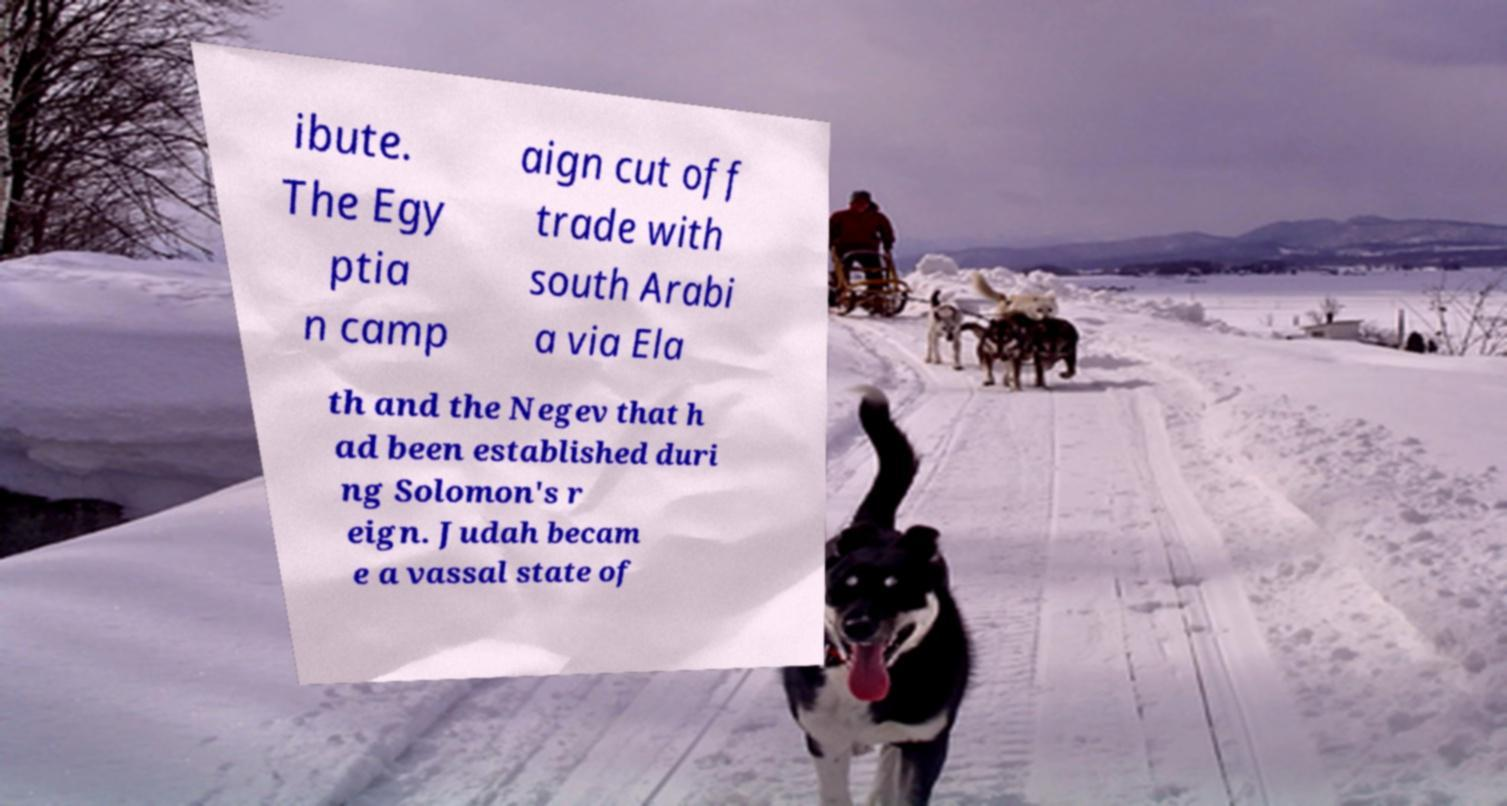For documentation purposes, I need the text within this image transcribed. Could you provide that? ibute. The Egy ptia n camp aign cut off trade with south Arabi a via Ela th and the Negev that h ad been established duri ng Solomon's r eign. Judah becam e a vassal state of 